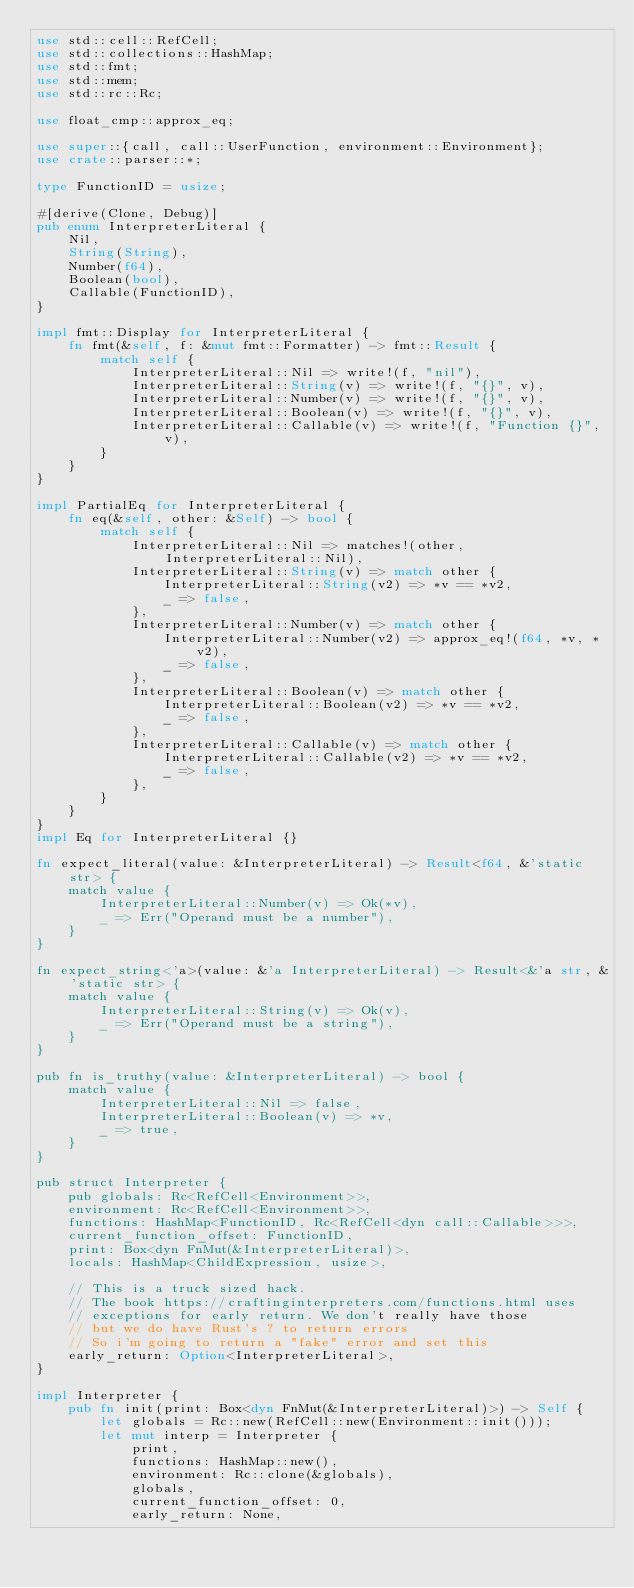<code> <loc_0><loc_0><loc_500><loc_500><_Rust_>use std::cell::RefCell;
use std::collections::HashMap;
use std::fmt;
use std::mem;
use std::rc::Rc;

use float_cmp::approx_eq;

use super::{call, call::UserFunction, environment::Environment};
use crate::parser::*;

type FunctionID = usize;

#[derive(Clone, Debug)]
pub enum InterpreterLiteral {
    Nil,
    String(String),
    Number(f64),
    Boolean(bool),
    Callable(FunctionID),
}

impl fmt::Display for InterpreterLiteral {
    fn fmt(&self, f: &mut fmt::Formatter) -> fmt::Result {
        match self {
            InterpreterLiteral::Nil => write!(f, "nil"),
            InterpreterLiteral::String(v) => write!(f, "{}", v),
            InterpreterLiteral::Number(v) => write!(f, "{}", v),
            InterpreterLiteral::Boolean(v) => write!(f, "{}", v),
            InterpreterLiteral::Callable(v) => write!(f, "Function {}", v),
        }
    }
}

impl PartialEq for InterpreterLiteral {
    fn eq(&self, other: &Self) -> bool {
        match self {
            InterpreterLiteral::Nil => matches!(other, InterpreterLiteral::Nil),
            InterpreterLiteral::String(v) => match other {
                InterpreterLiteral::String(v2) => *v == *v2,
                _ => false,
            },
            InterpreterLiteral::Number(v) => match other {
                InterpreterLiteral::Number(v2) => approx_eq!(f64, *v, *v2),
                _ => false,
            },
            InterpreterLiteral::Boolean(v) => match other {
                InterpreterLiteral::Boolean(v2) => *v == *v2,
                _ => false,
            },
            InterpreterLiteral::Callable(v) => match other {
                InterpreterLiteral::Callable(v2) => *v == *v2,
                _ => false,
            },
        }
    }
}
impl Eq for InterpreterLiteral {}

fn expect_literal(value: &InterpreterLiteral) -> Result<f64, &'static str> {
    match value {
        InterpreterLiteral::Number(v) => Ok(*v),
        _ => Err("Operand must be a number"),
    }
}

fn expect_string<'a>(value: &'a InterpreterLiteral) -> Result<&'a str, &'static str> {
    match value {
        InterpreterLiteral::String(v) => Ok(v),
        _ => Err("Operand must be a string"),
    }
}

pub fn is_truthy(value: &InterpreterLiteral) -> bool {
    match value {
        InterpreterLiteral::Nil => false,
        InterpreterLiteral::Boolean(v) => *v,
        _ => true,
    }
}

pub struct Interpreter {
    pub globals: Rc<RefCell<Environment>>,
    environment: Rc<RefCell<Environment>>,
    functions: HashMap<FunctionID, Rc<RefCell<dyn call::Callable>>>,
    current_function_offset: FunctionID,
    print: Box<dyn FnMut(&InterpreterLiteral)>,
    locals: HashMap<ChildExpression, usize>,

    // This is a truck sized hack.
    // The book https://craftinginterpreters.com/functions.html uses
    // exceptions for early return. We don't really have those
    // but we do have Rust's ? to return errors
    // So i'm going to return a "fake" error and set this
    early_return: Option<InterpreterLiteral>,
}

impl Interpreter {
    pub fn init(print: Box<dyn FnMut(&InterpreterLiteral)>) -> Self {
        let globals = Rc::new(RefCell::new(Environment::init()));
        let mut interp = Interpreter {
            print,
            functions: HashMap::new(),
            environment: Rc::clone(&globals),
            globals,
            current_function_offset: 0,
            early_return: None,</code> 